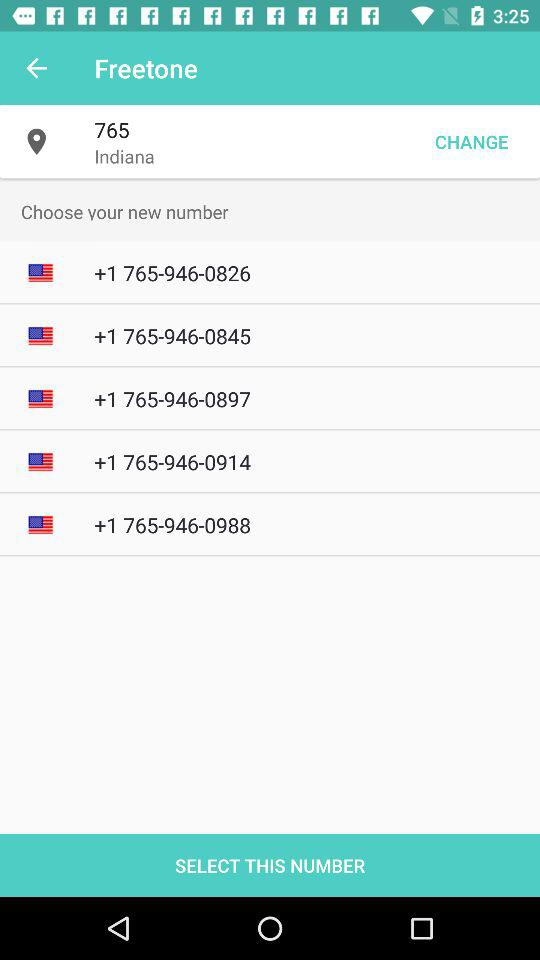What is the selected location? The selected location is 765, Indiana. 